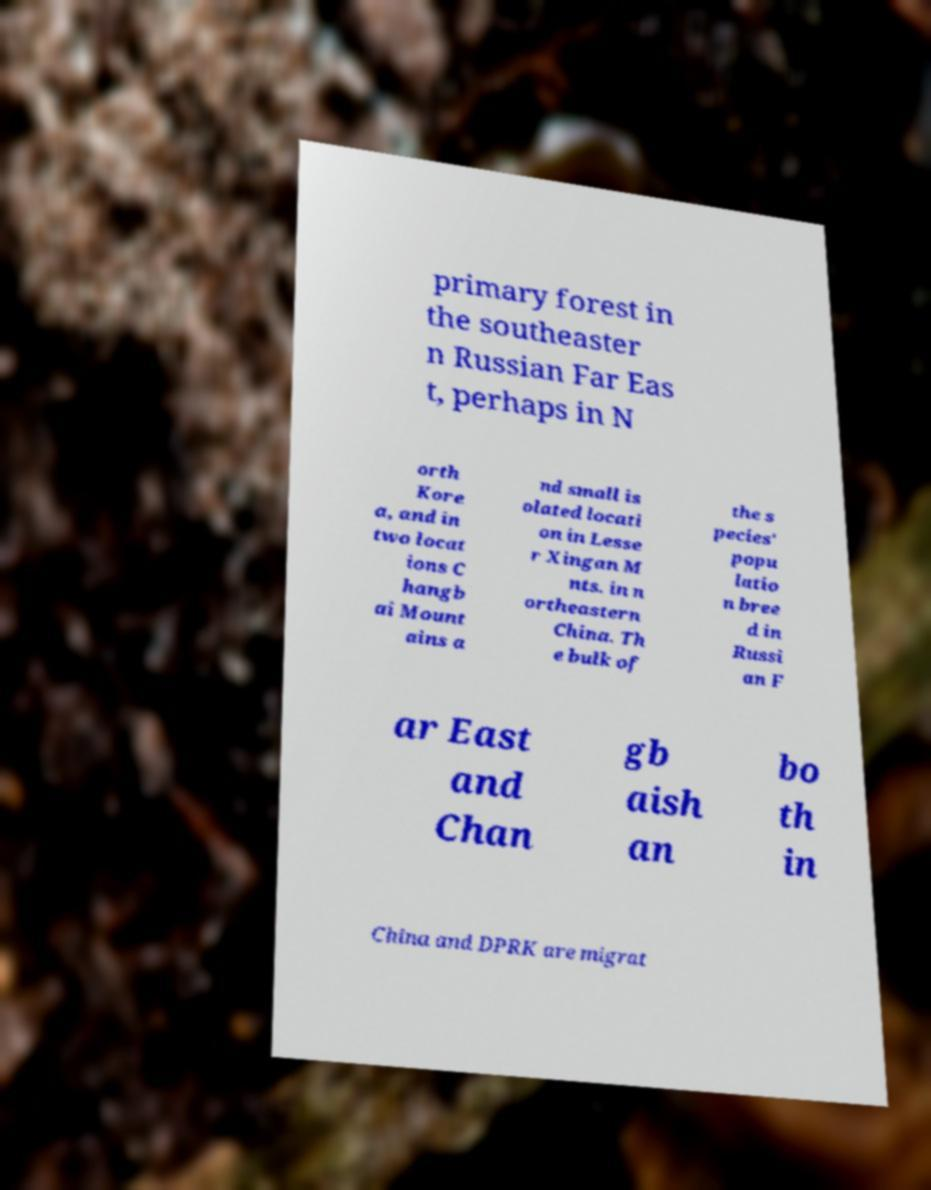Could you extract and type out the text from this image? primary forest in the southeaster n Russian Far Eas t, perhaps in N orth Kore a, and in two locat ions C hangb ai Mount ains a nd small is olated locati on in Lesse r Xingan M nts. in n ortheastern China. Th e bulk of the s pecies' popu latio n bree d in Russi an F ar East and Chan gb aish an bo th in China and DPRK are migrat 